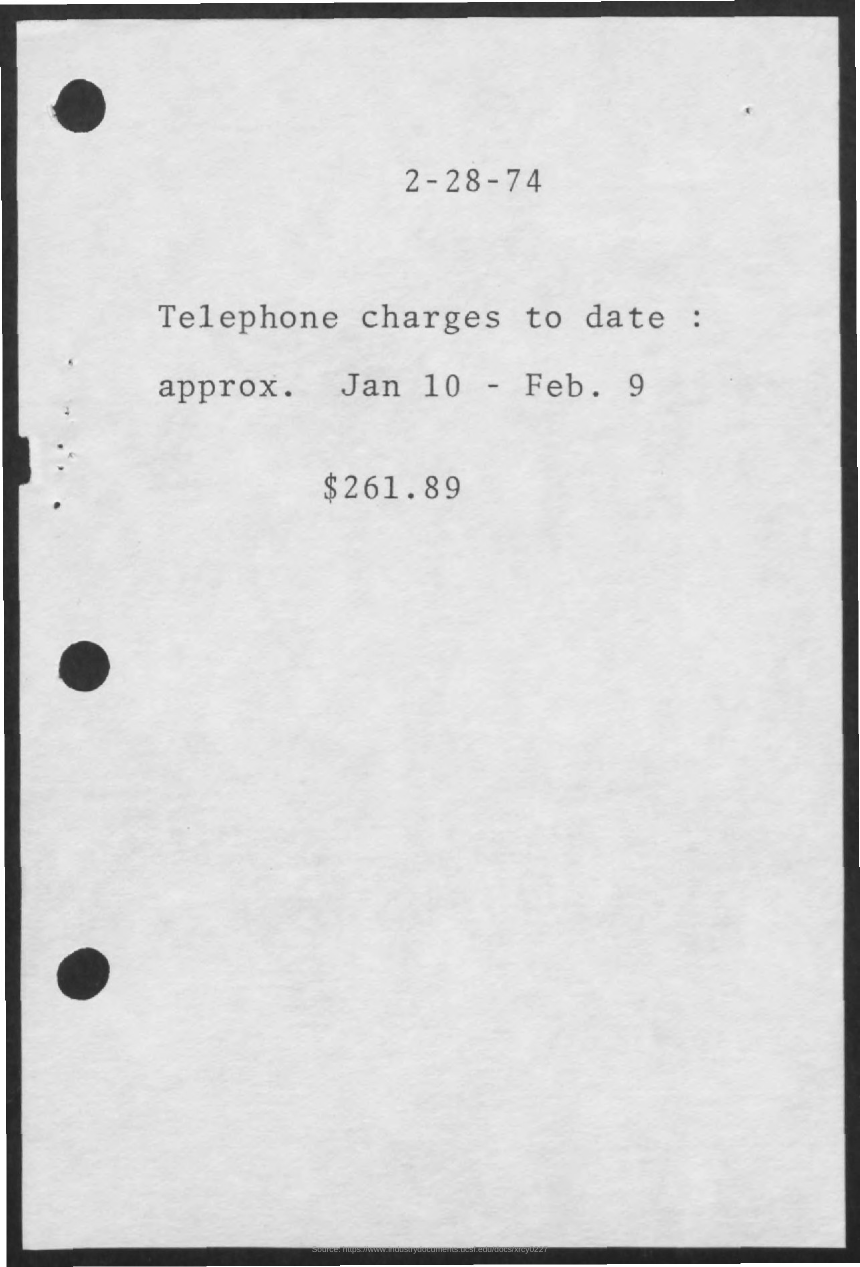What can you tell me about the style of the document? The document features a simple typewritten format that was common in the 1970s before the widespread use of personal computers. It's straightforward and practical, mostly utilitarian without any elaborate design elements. Does the simplicity of the document tell us anything specific? Its simplicity suggests it could be from a small business or a period-specific government agency document. It's focused on conveying essential information without any unnecessary embellishments. 